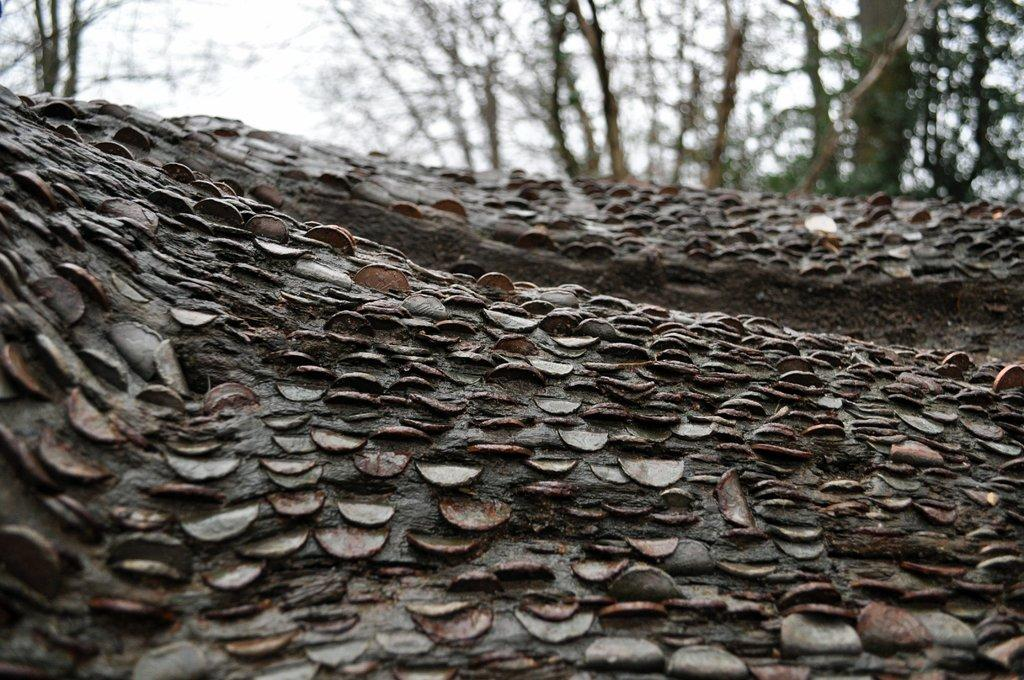What is the main subject in the center of the image? There is a branch of a tree in the center of the image. What else can be seen in the image besides the branch? Trees and the sky are visible in the background of the image. Can you tell me how many bees are sitting on the branch in the image? There are no bees present on the branch in the image. What part of the tree is the branch from? The provided facts do not specify which part of the tree the branch is from. 